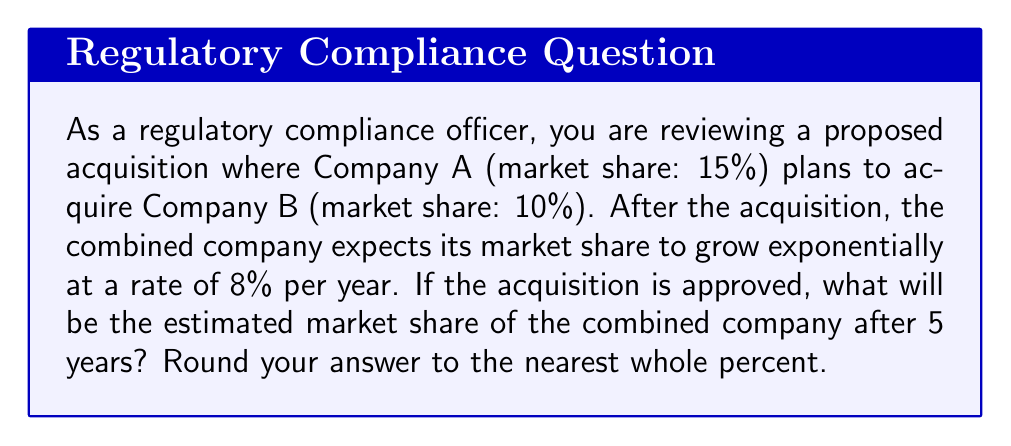Could you help me with this problem? To solve this problem, we'll use the exponential growth formula:

$$ A = P(1 + r)^t $$

Where:
$A$ = Final amount
$P$ = Initial amount (principal)
$r$ = Growth rate (as a decimal)
$t$ = Time period

Let's break down the problem step-by-step:

1. Calculate the initial combined market share:
   $P = 15\% + 10\% = 25\%$ or $0.25$

2. Convert the growth rate to a decimal:
   $r = 8\% = 0.08$

3. Set the time period:
   $t = 5$ years

4. Apply the exponential growth formula:
   $$ A = 0.25(1 + 0.08)^5 $$

5. Calculate:
   $$ A = 0.25(1.08)^5 $$
   $$ A = 0.25(1.4693280768) $$
   $$ A = 0.3673320192 $$

6. Convert to a percentage:
   $$ A = 36.73320192\% $$

7. Round to the nearest whole percent:
   $$ A \approx 37\% $$
Answer: 37% 